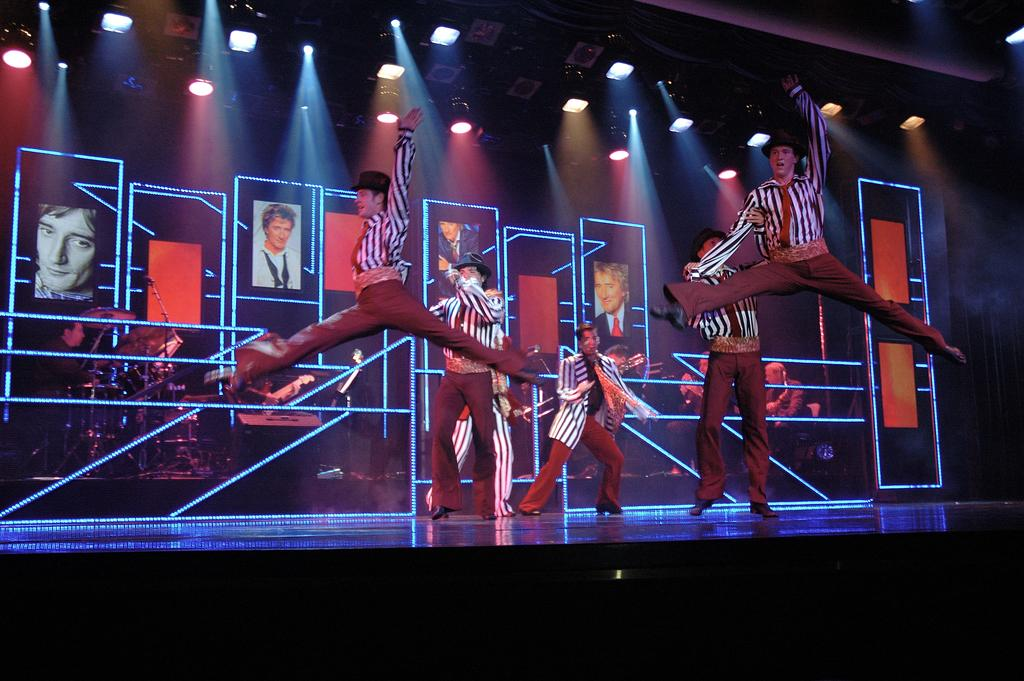What can be seen in the image involving a group of people? There is a group of boys in the image. What are the boys doing in the image? The boys are performing an activity on a stage. What else is visible in the image besides the boys? There are pictures of people and beautiful lights near the roof of the stage. What type of ship can be seen sailing in the background of the image? There is no ship visible in the image; it features a group of boys performing on a stage with pictures of people and beautiful lights near the roof. 